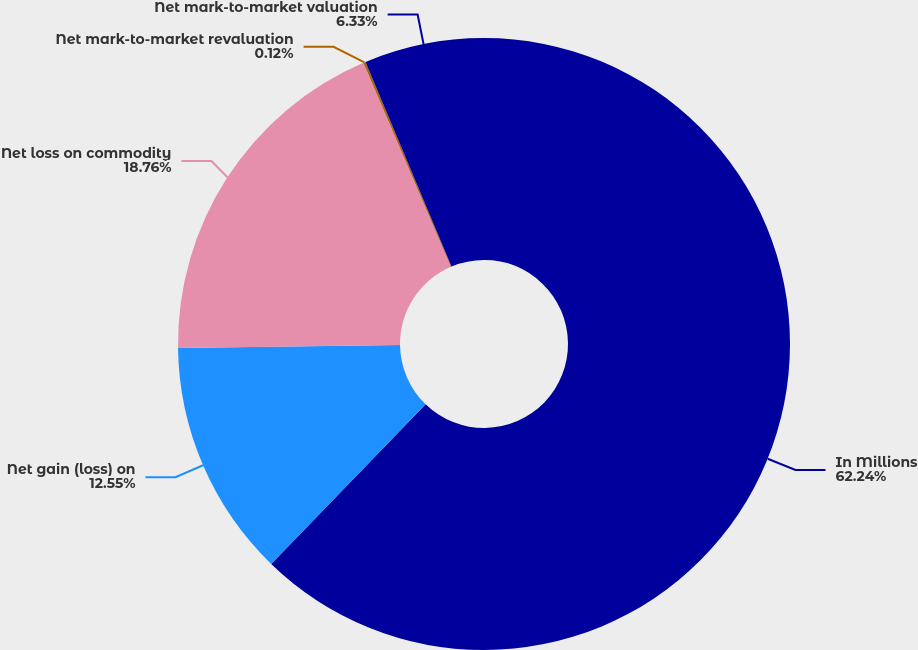Convert chart to OTSL. <chart><loc_0><loc_0><loc_500><loc_500><pie_chart><fcel>In Millions<fcel>Net gain (loss) on<fcel>Net loss on commodity<fcel>Net mark-to-market revaluation<fcel>Net mark-to-market valuation<nl><fcel>62.24%<fcel>12.55%<fcel>18.76%<fcel>0.12%<fcel>6.33%<nl></chart> 